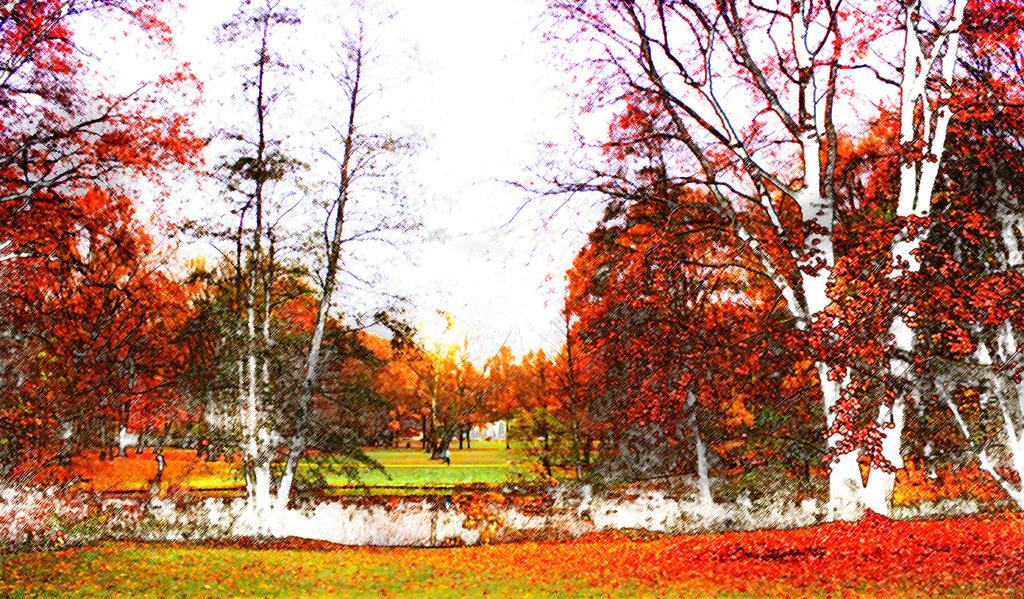What type of vegetation can be seen in the image? There are trees in the image. What is on the ground beneath the trees? Leaves are present on the ground in the image. What can be seen in the background of the image? The sky is visible in the background of the image. How many servants are visible in the image? There are no servants present in the image. What type of hill can be seen in the image? There is no hill present in the image. 